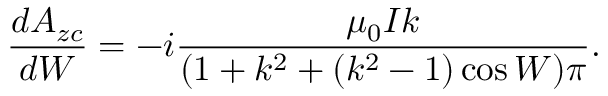Convert formula to latex. <formula><loc_0><loc_0><loc_500><loc_500>\frac { d A _ { z c } } { d W } = - i \frac { \mu _ { 0 } I k } { ( 1 + k ^ { 2 } + ( k ^ { 2 } - 1 ) \cos W ) \pi } .</formula> 